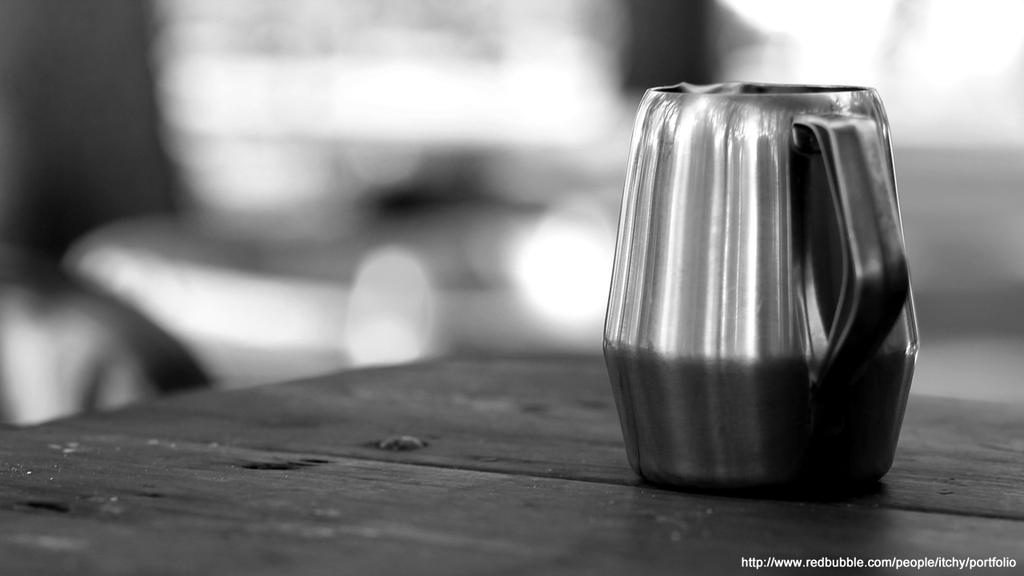What is the color scheme of the image? The image is black and white. What object can be seen on a table in the image? There is a cup on a table in the image. Can you describe the background of the image? The background of the image is blurred. What additional information is provided at the bottom of the image? There is text visible at the bottom of the image. What type of hair can be seen on the nation in the image? There is no nation or hair present in the image; it is a black and white image with a cup on a table and text at the bottom. 